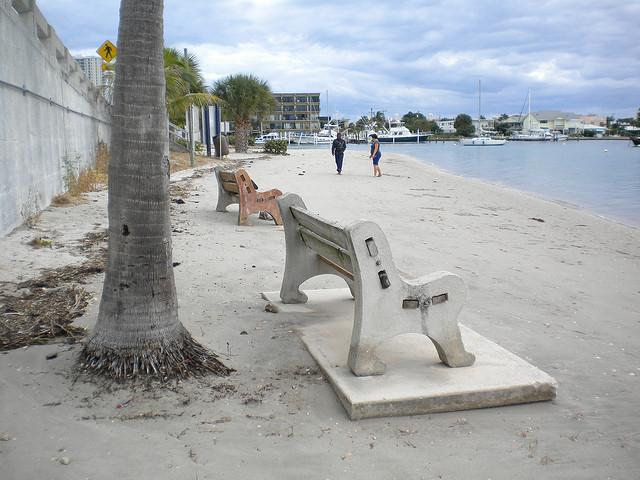What are the benches for? Please explain your reasoning. resting. The benches are permanently mounted so they could not have washed ashore or be for sale and they would sink if placed in water so they can't be surfed on. 